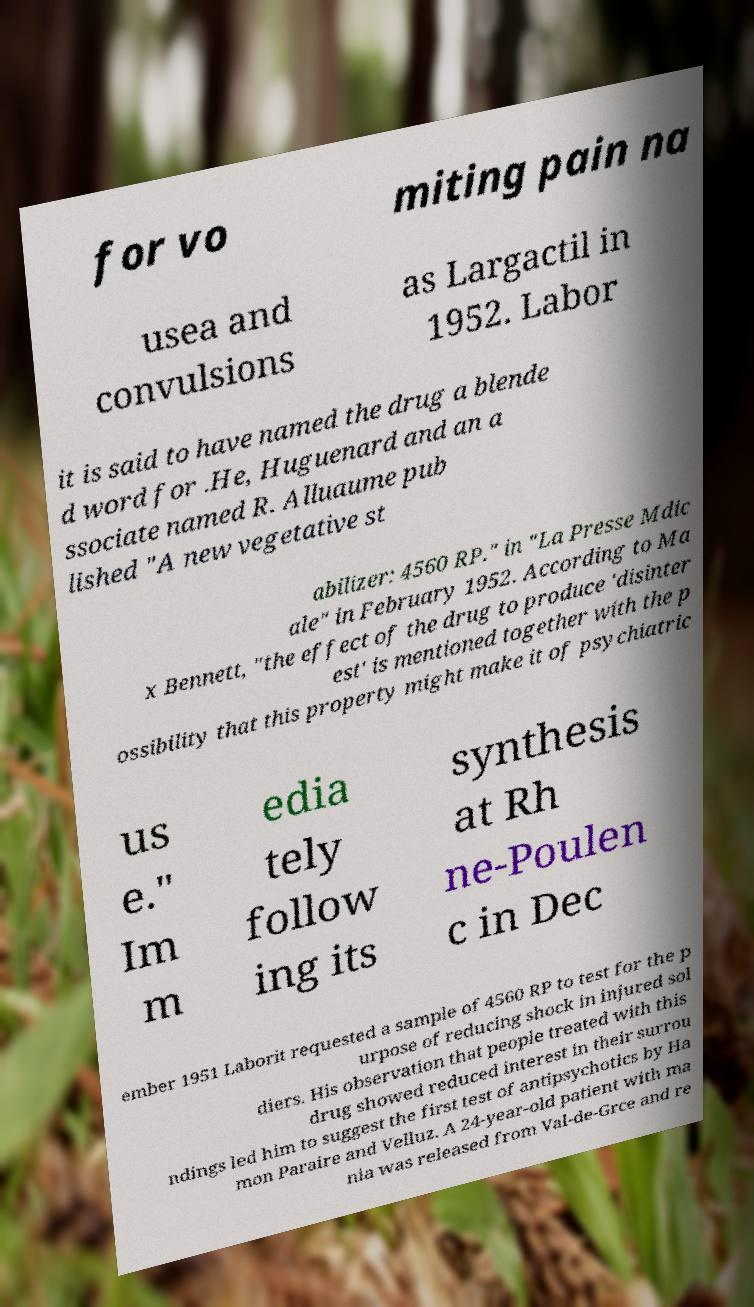Could you assist in decoding the text presented in this image and type it out clearly? for vo miting pain na usea and convulsions as Largactil in 1952. Labor it is said to have named the drug a blende d word for .He, Huguenard and an a ssociate named R. Alluaume pub lished "A new vegetative st abilizer: 4560 RP." in "La Presse Mdic ale" in February 1952. According to Ma x Bennett, "the effect of the drug to produce 'disinter est' is mentioned together with the p ossibility that this property might make it of psychiatric us e." Im m edia tely follow ing its synthesis at Rh ne-Poulen c in Dec ember 1951 Laborit requested a sample of 4560 RP to test for the p urpose of reducing shock in injured sol diers. His observation that people treated with this drug showed reduced interest in their surrou ndings led him to suggest the first test of antipsychotics by Ha mon Paraire and Velluz. A 24-year-old patient with ma nia was released from Val-de-Grce and re 